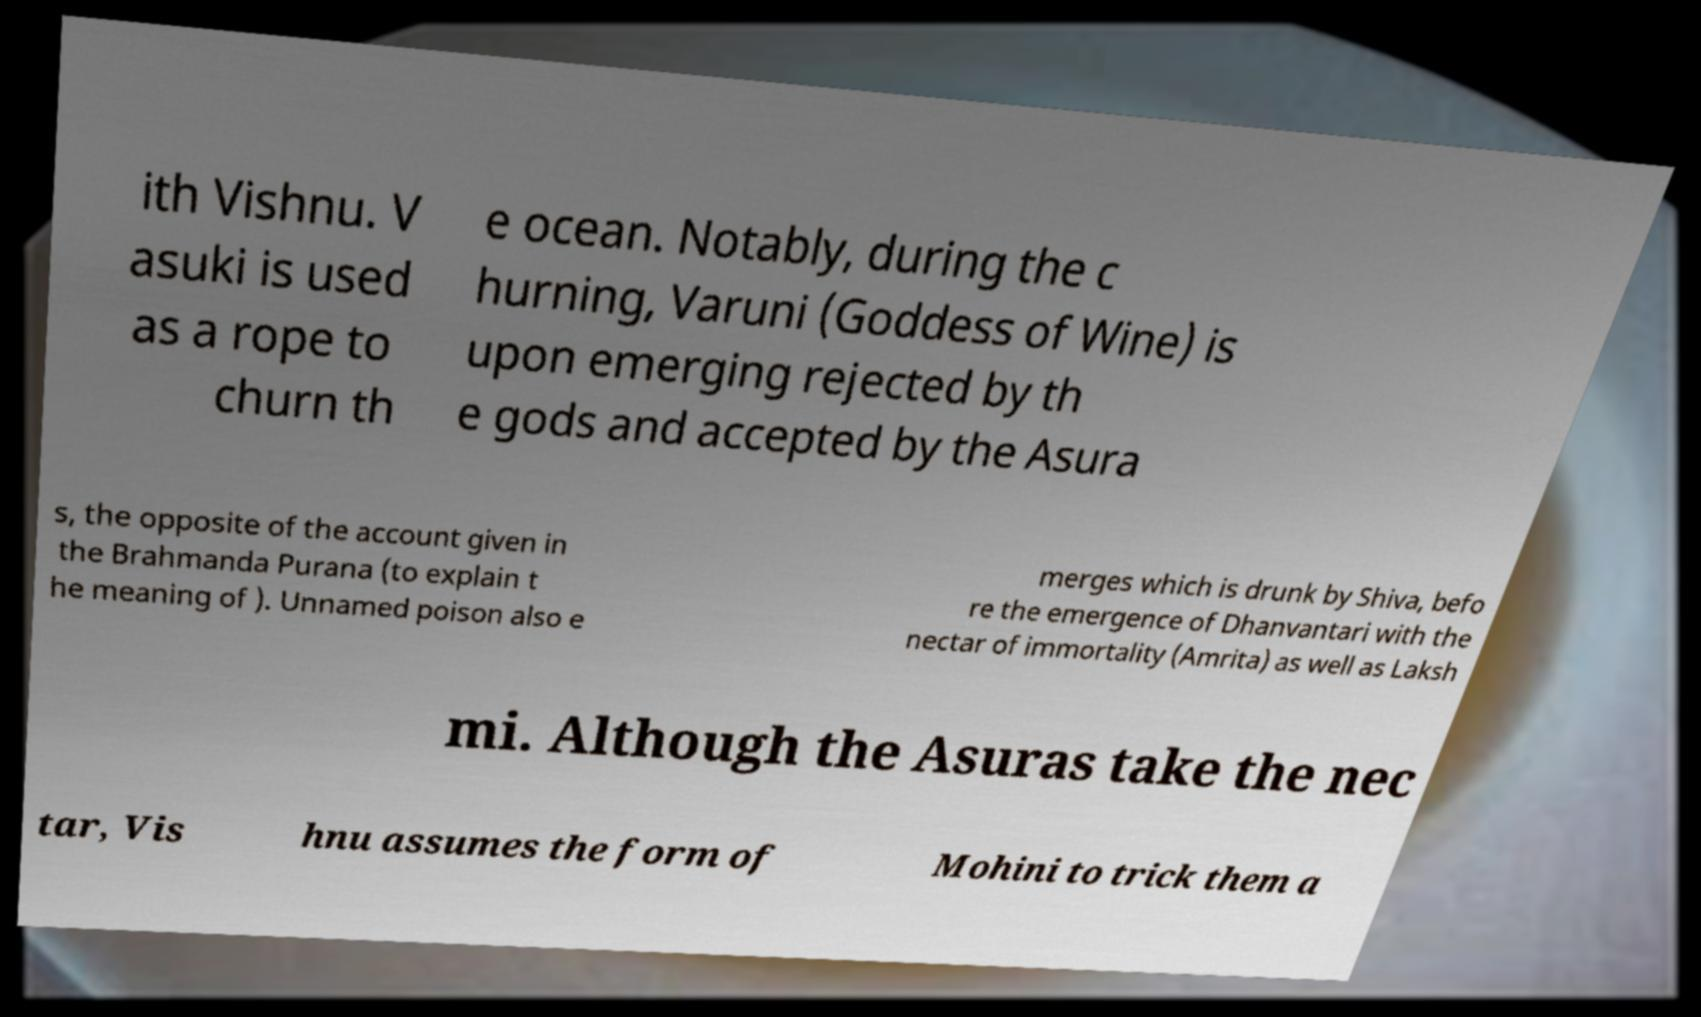Please read and relay the text visible in this image. What does it say? ith Vishnu. V asuki is used as a rope to churn th e ocean. Notably, during the c hurning, Varuni (Goddess of Wine) is upon emerging rejected by th e gods and accepted by the Asura s, the opposite of the account given in the Brahmanda Purana (to explain t he meaning of ). Unnamed poison also e merges which is drunk by Shiva, befo re the emergence of Dhanvantari with the nectar of immortality (Amrita) as well as Laksh mi. Although the Asuras take the nec tar, Vis hnu assumes the form of Mohini to trick them a 